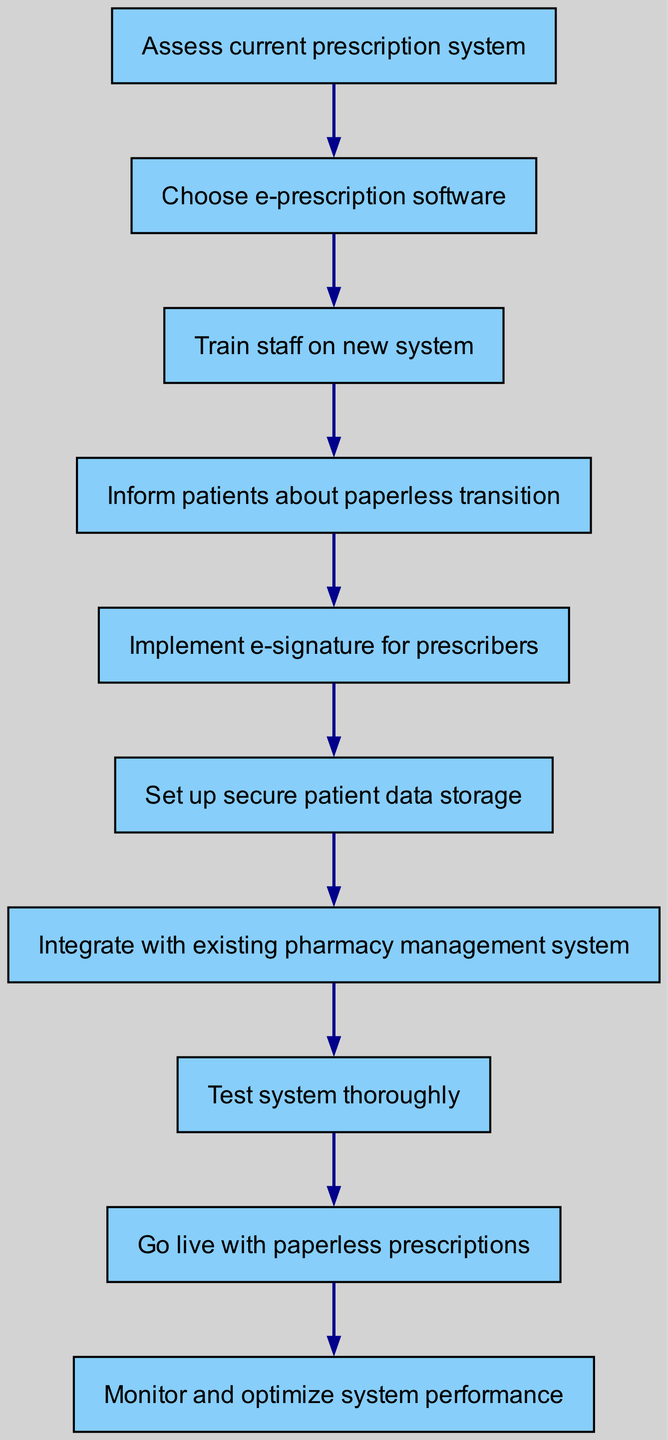What is the first step in the diagram? The diagram starts with the node labeled "Assess current prescription system," which is the first step in the implementation process.
Answer: Assess current prescription system How many total steps are there to implement the paperless prescription system? By counting the nodes in the diagram, there are ten distinct steps outlined for implementing the system, from the assessment to monitoring performance.
Answer: Ten What is the last step in the flowchart? The final node in the flowchart is "Monitor and optimize system performance," indicating the conclusion of the implementation process.
Answer: Monitor and optimize system performance What step follows the training of staff on the new system? Following the "Train staff on new system," the next step indicated in the flowchart is "Inform patients about paperless transition."
Answer: Inform patients about paperless transition Which task involves communication with prescribers? The task that involves communication with prescribers is "Implement e-signature for prescribers," as it directly relates to their participation in the new system.
Answer: Implement e-signature for prescribers How does the testing phase relate to the implementation process? The "Test system thoroughly" step is crucial as it follows the integration with the pharmacy management system, ensuring that everything functions correctly before going live.
Answer: Ensures correct functionality What action must be taken before going live with paperless prescriptions? Before "Go live with paperless prescriptions," the preceding step is "Test system thoroughly," which is mandated to verify system readiness.
Answer: Test system thoroughly Identify a key action when transitioning patients to a paperless system. The key action to transition patients is "Inform patients about paperless transition," which is essential for ensuring they are aware of the changes.
Answer: Inform patients about paperless transition What is the main focus of the sixth step in the diagram? The sixth step focuses on "Set up secure patient data storage," emphasizing the importance of protecting patient information in a digital format.
Answer: Set up secure patient data storage 